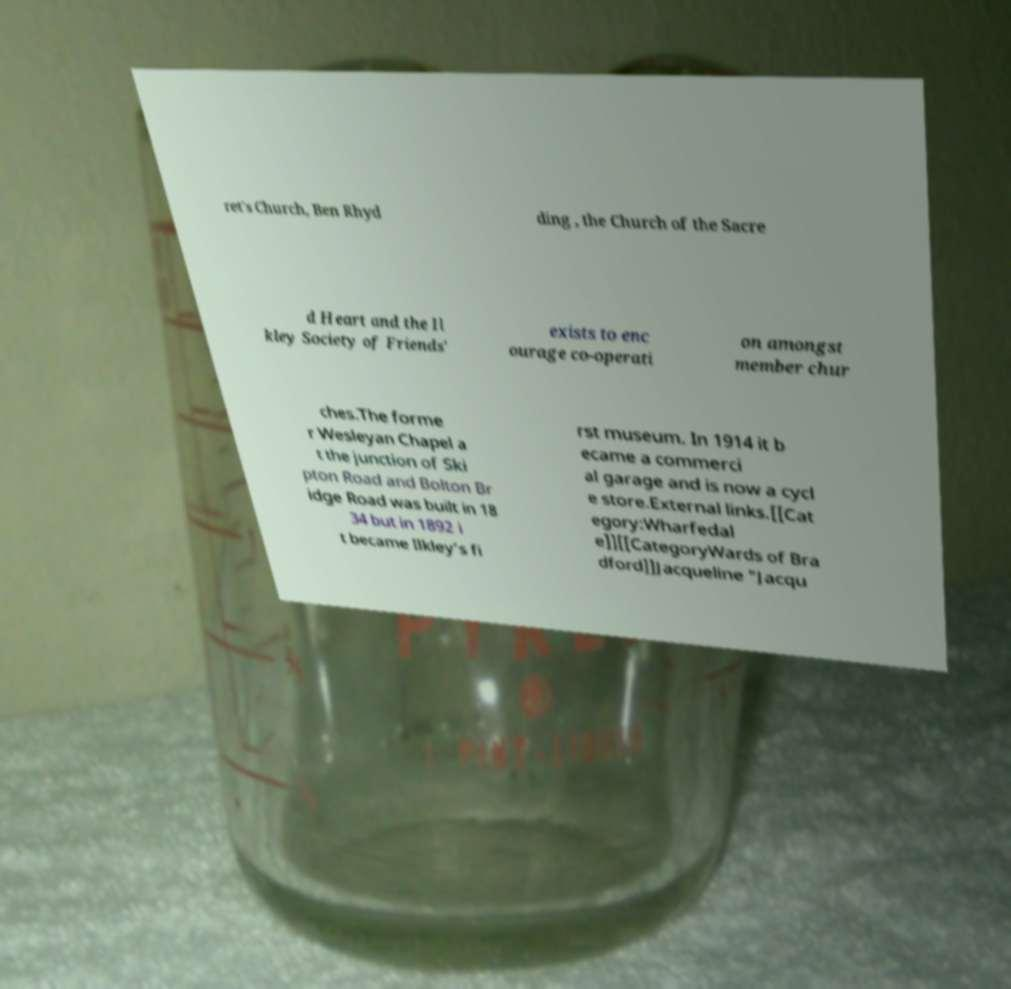There's text embedded in this image that I need extracted. Can you transcribe it verbatim? ret's Church, Ben Rhyd ding , the Church of the Sacre d Heart and the Il kley Society of Friends' exists to enc ourage co-operati on amongst member chur ches.The forme r Wesleyan Chapel a t the junction of Ski pton Road and Bolton Br idge Road was built in 18 34 but in 1892 i t became Ilkley’s fi rst museum. In 1914 it b ecame a commerci al garage and is now a cycl e store.External links.[[Cat egory:Wharfedal e]][[CategoryWards of Bra dford]]Jacqueline "Jacqu 